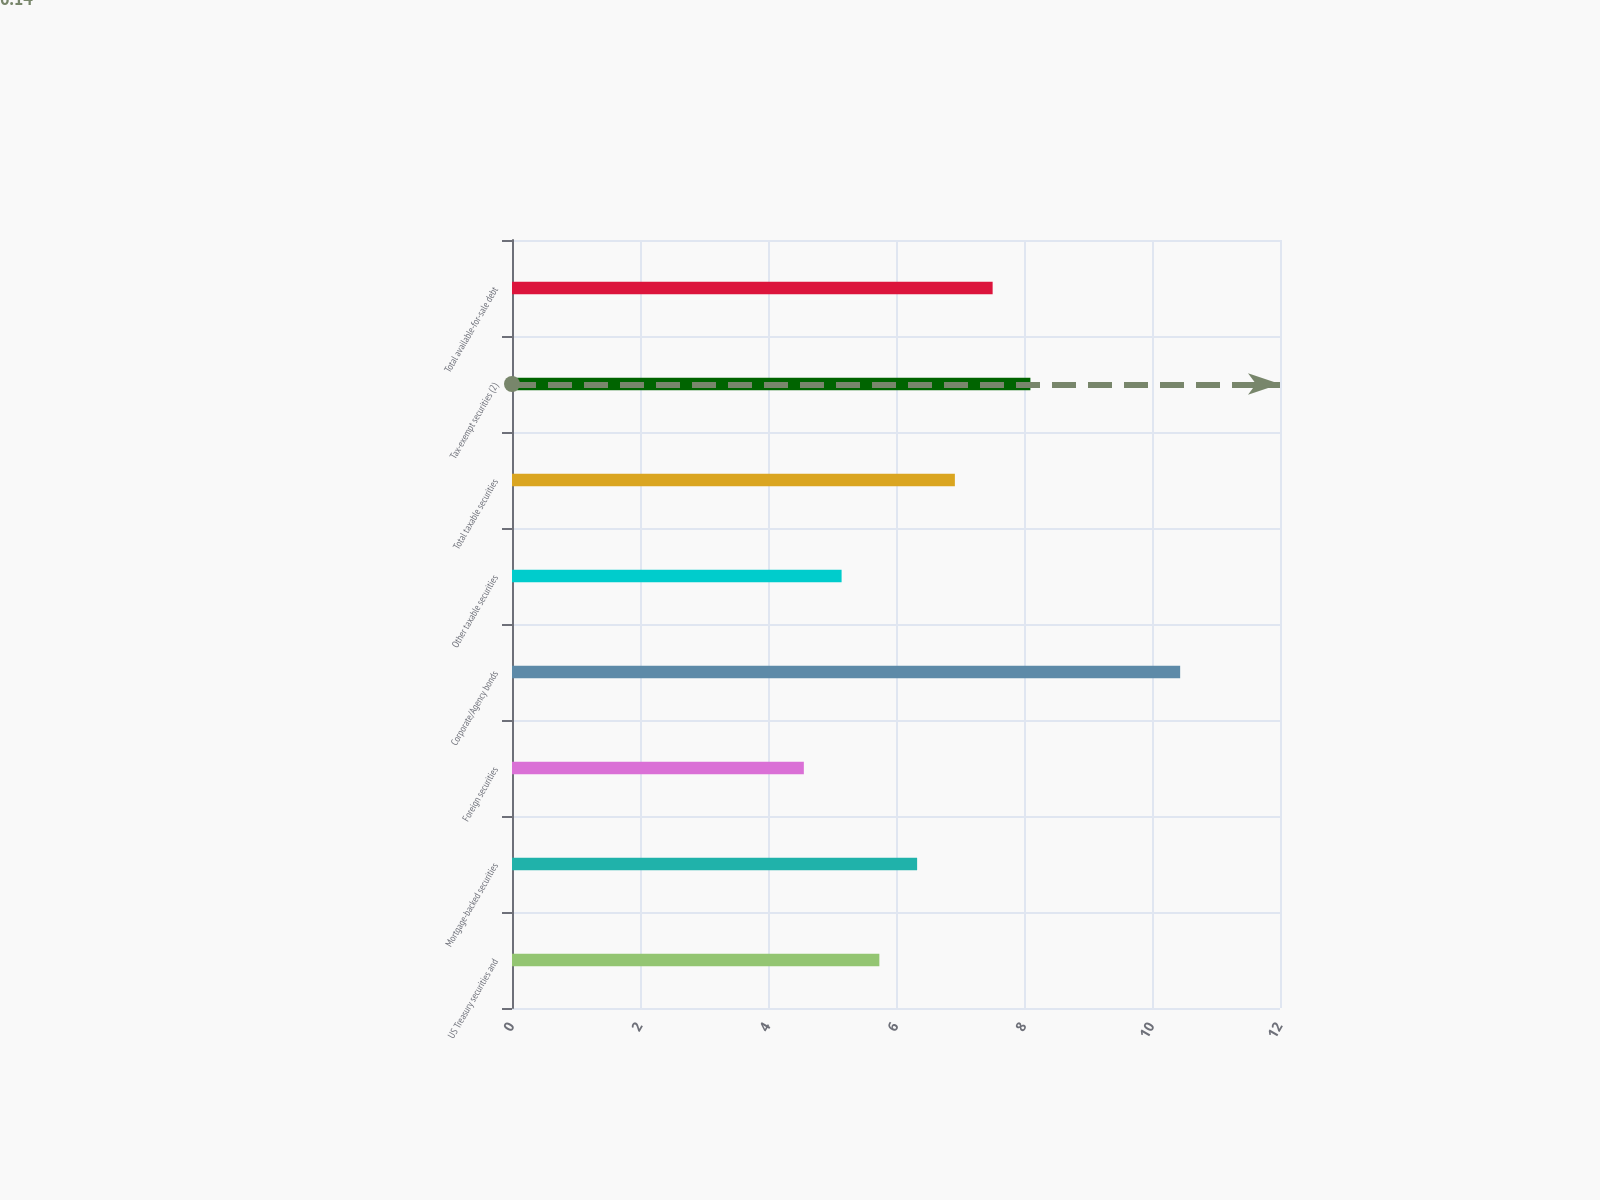<chart> <loc_0><loc_0><loc_500><loc_500><bar_chart><fcel>US Treasury securities and<fcel>Mortgage-backed securities<fcel>Foreign securities<fcel>Corporate/Agency bonds<fcel>Other taxable securities<fcel>Total taxable securities<fcel>Tax-exempt securities (2)<fcel>Total available-for-sale debt<nl><fcel>5.74<fcel>6.33<fcel>4.56<fcel>10.44<fcel>5.15<fcel>6.92<fcel>8.1<fcel>7.51<nl></chart> 